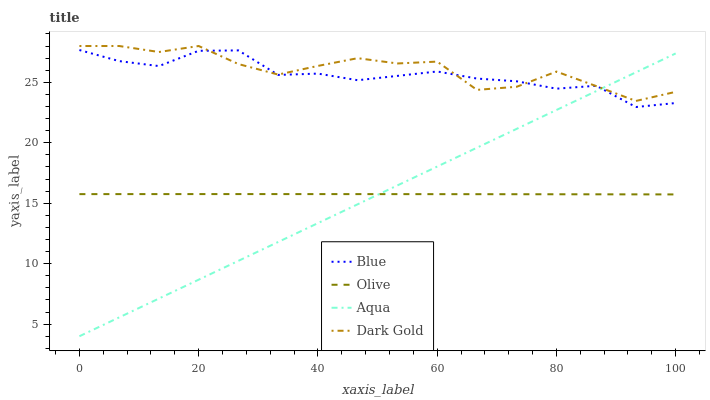Does Aqua have the minimum area under the curve?
Answer yes or no. Yes. Does Dark Gold have the maximum area under the curve?
Answer yes or no. Yes. Does Olive have the minimum area under the curve?
Answer yes or no. No. Does Olive have the maximum area under the curve?
Answer yes or no. No. Is Aqua the smoothest?
Answer yes or no. Yes. Is Dark Gold the roughest?
Answer yes or no. Yes. Is Olive the smoothest?
Answer yes or no. No. Is Olive the roughest?
Answer yes or no. No. Does Olive have the lowest value?
Answer yes or no. No. Does Dark Gold have the highest value?
Answer yes or no. Yes. Does Aqua have the highest value?
Answer yes or no. No. Is Olive less than Blue?
Answer yes or no. Yes. Is Dark Gold greater than Olive?
Answer yes or no. Yes. Does Blue intersect Aqua?
Answer yes or no. Yes. Is Blue less than Aqua?
Answer yes or no. No. Is Blue greater than Aqua?
Answer yes or no. No. Does Olive intersect Blue?
Answer yes or no. No. 